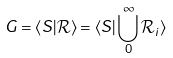Convert formula to latex. <formula><loc_0><loc_0><loc_500><loc_500>G = \langle S | \mathcal { R } \rangle = \langle S | \bigcup _ { 0 } ^ { \infty } \mathcal { R } _ { i } \rangle</formula> 